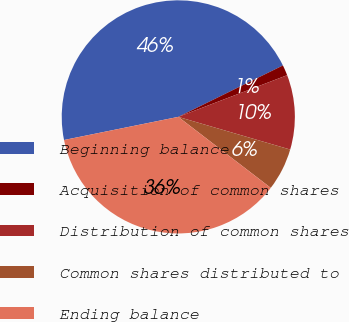Convert chart. <chart><loc_0><loc_0><loc_500><loc_500><pie_chart><fcel>Beginning balance<fcel>Acquisition of common shares<fcel>Distribution of common shares<fcel>Common shares distributed to<fcel>Ending balance<nl><fcel>45.91%<fcel>1.45%<fcel>10.34%<fcel>5.9%<fcel>36.4%<nl></chart> 